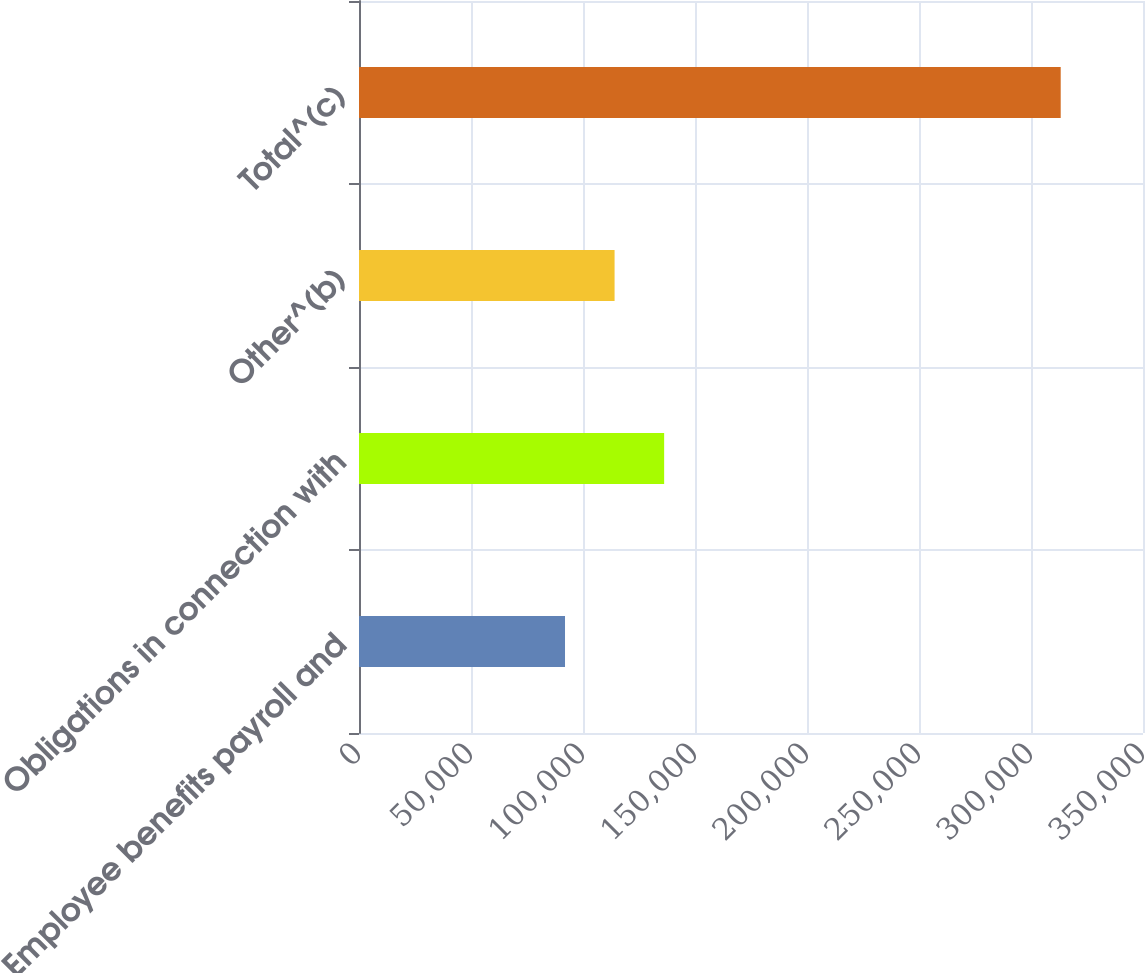Convert chart. <chart><loc_0><loc_0><loc_500><loc_500><bar_chart><fcel>Employee benefits payroll and<fcel>Obligations in connection with<fcel>Other^(b)<fcel>Total^(c)<nl><fcel>91970<fcel>136228<fcel>114099<fcel>313259<nl></chart> 